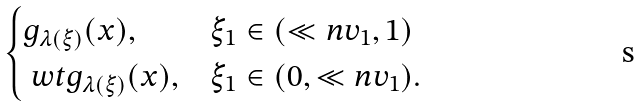Convert formula to latex. <formula><loc_0><loc_0><loc_500><loc_500>\begin{cases} g _ { \lambda ( \xi ) } ( x ) , & \xi _ { 1 } \in ( \ll n v _ { 1 } , 1 ) \\ \ w t g _ { \lambda ( \xi ) } ( x ) , & \xi _ { 1 } \in ( 0 , \ll n v _ { 1 } ) . \end{cases}</formula> 